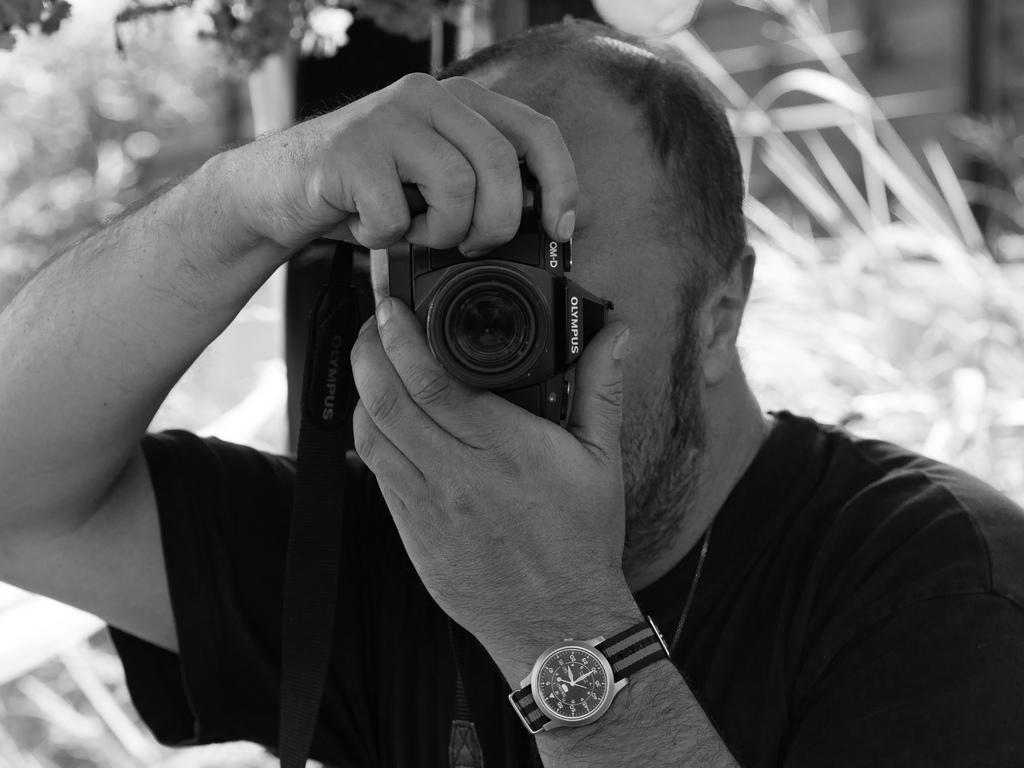Please provide a concise description of this image. In the center we can see the man he is holding camera. And coming to the background we can see some trees. 